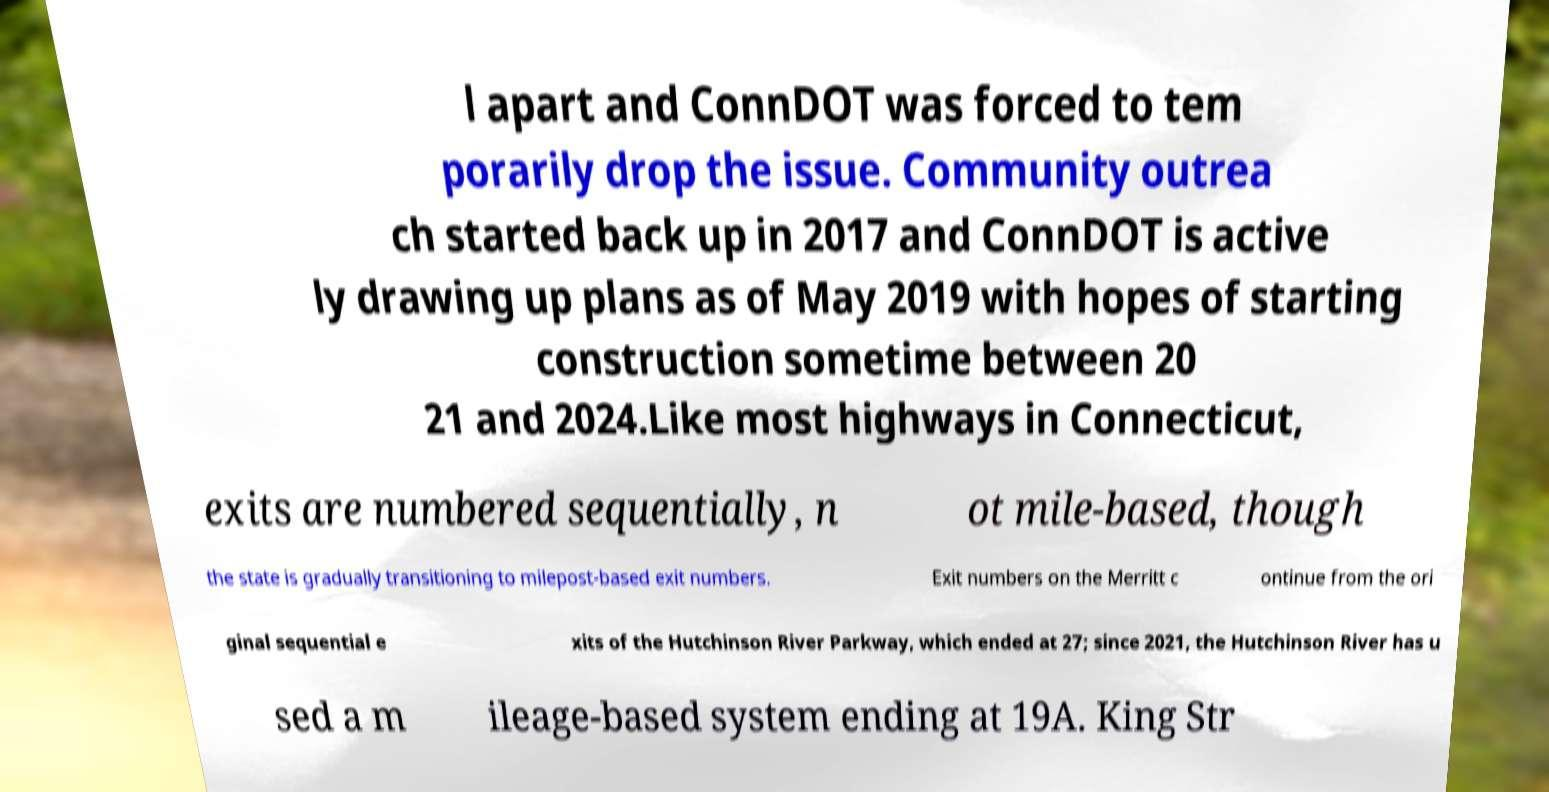Please identify and transcribe the text found in this image. l apart and ConnDOT was forced to tem porarily drop the issue. Community outrea ch started back up in 2017 and ConnDOT is active ly drawing up plans as of May 2019 with hopes of starting construction sometime between 20 21 and 2024.Like most highways in Connecticut, exits are numbered sequentially, n ot mile-based, though the state is gradually transitioning to milepost-based exit numbers. Exit numbers on the Merritt c ontinue from the ori ginal sequential e xits of the Hutchinson River Parkway, which ended at 27; since 2021, the Hutchinson River has u sed a m ileage-based system ending at 19A. King Str 